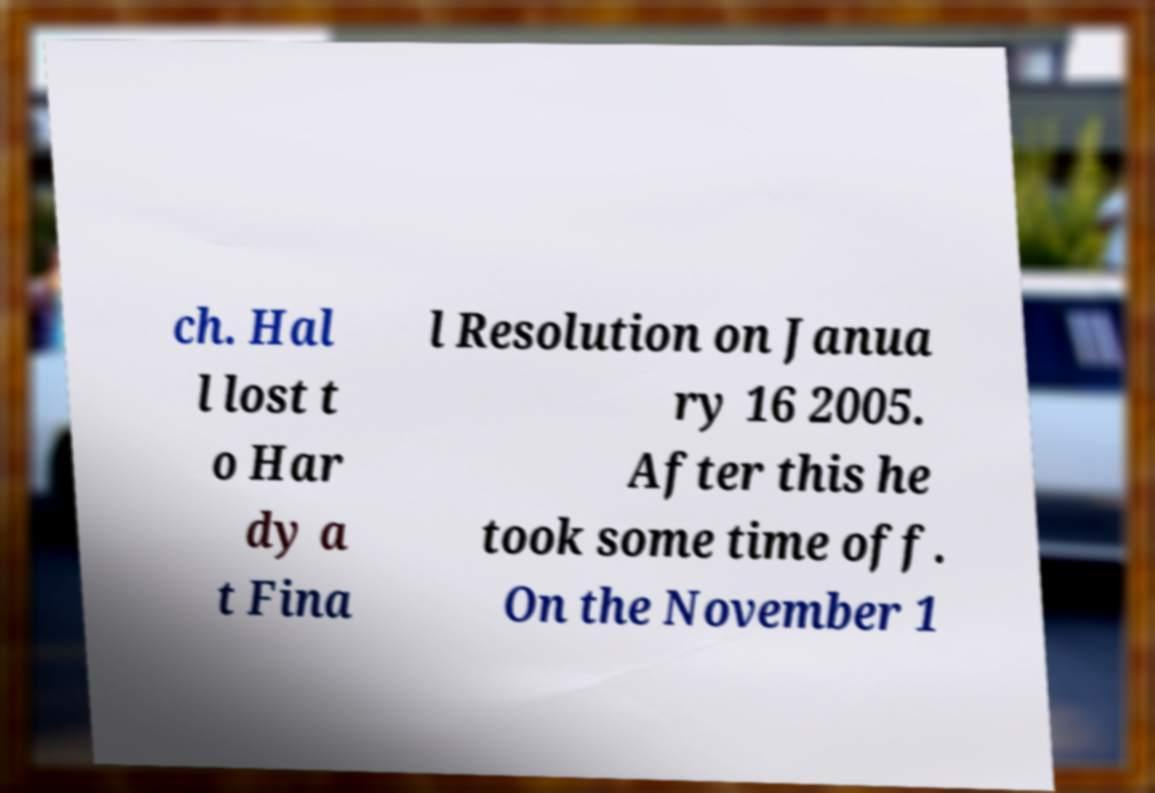Please read and relay the text visible in this image. What does it say? ch. Hal l lost t o Har dy a t Fina l Resolution on Janua ry 16 2005. After this he took some time off. On the November 1 